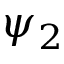Convert formula to latex. <formula><loc_0><loc_0><loc_500><loc_500>\psi _ { 2 }</formula> 